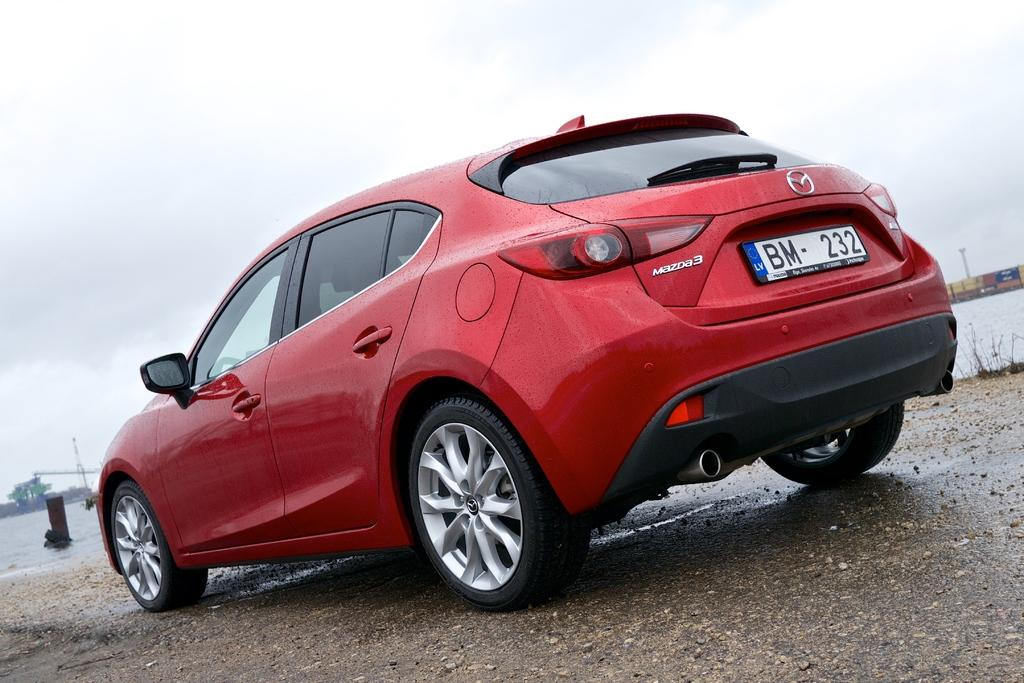What is the main subject of the image? There is a car in the middle of the image. What can be seen in the background of the image? There is water and clouds visible in the background of the image. How does the car express regret in the image? Cars do not have the ability to express regret, as they are inanimate objects. 